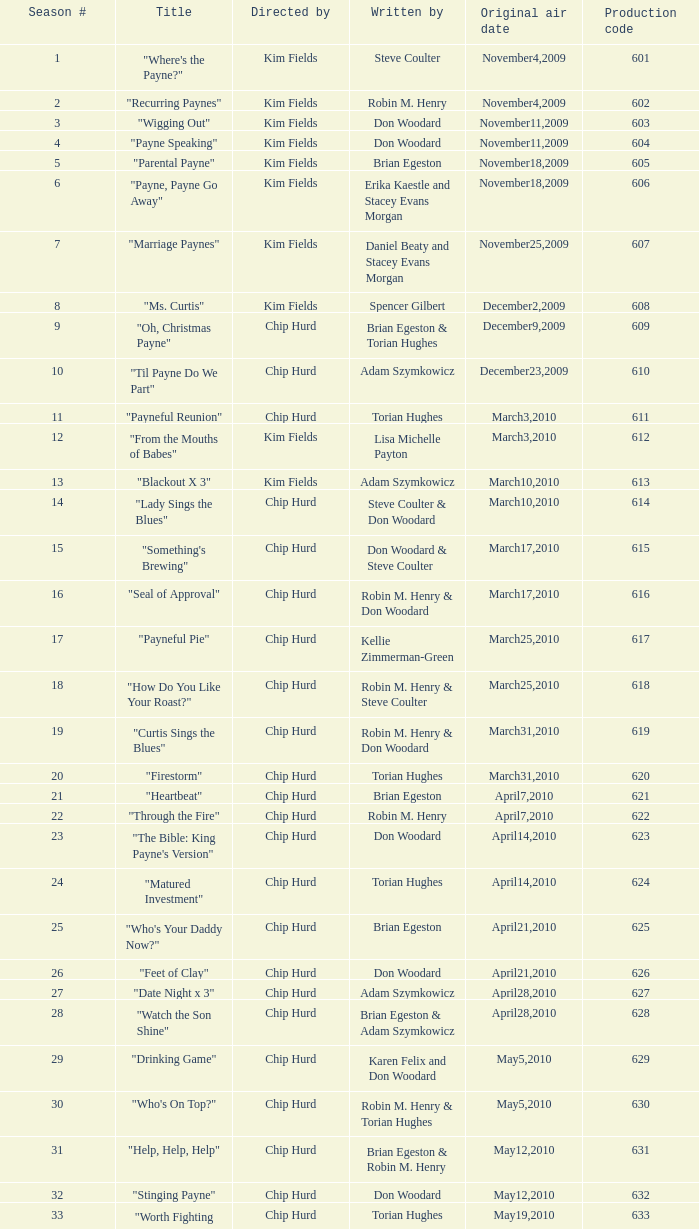What is the original air dates for the title "firestorm"? March31,2010. 